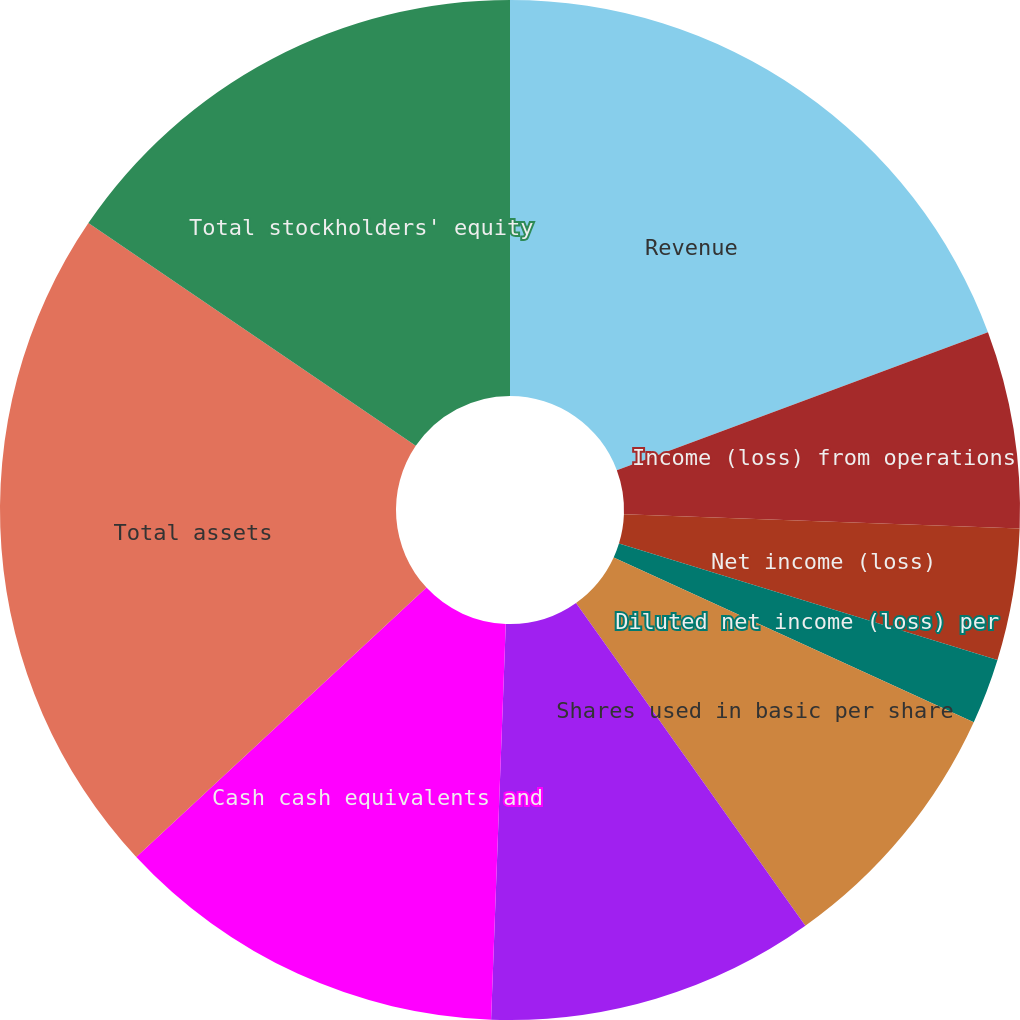Convert chart to OTSL. <chart><loc_0><loc_0><loc_500><loc_500><pie_chart><fcel>Revenue<fcel>Income (loss) from operations<fcel>Net income (loss)<fcel>Basic net income (loss) per<fcel>Diluted net income (loss) per<fcel>Shares used in basic per share<fcel>Shares used in diluted per<fcel>Cash cash equivalents and<fcel>Total assets<fcel>Total stockholders' equity<nl><fcel>19.33%<fcel>6.25%<fcel>4.17%<fcel>0.0%<fcel>2.08%<fcel>8.34%<fcel>10.42%<fcel>12.5%<fcel>21.42%<fcel>15.49%<nl></chart> 